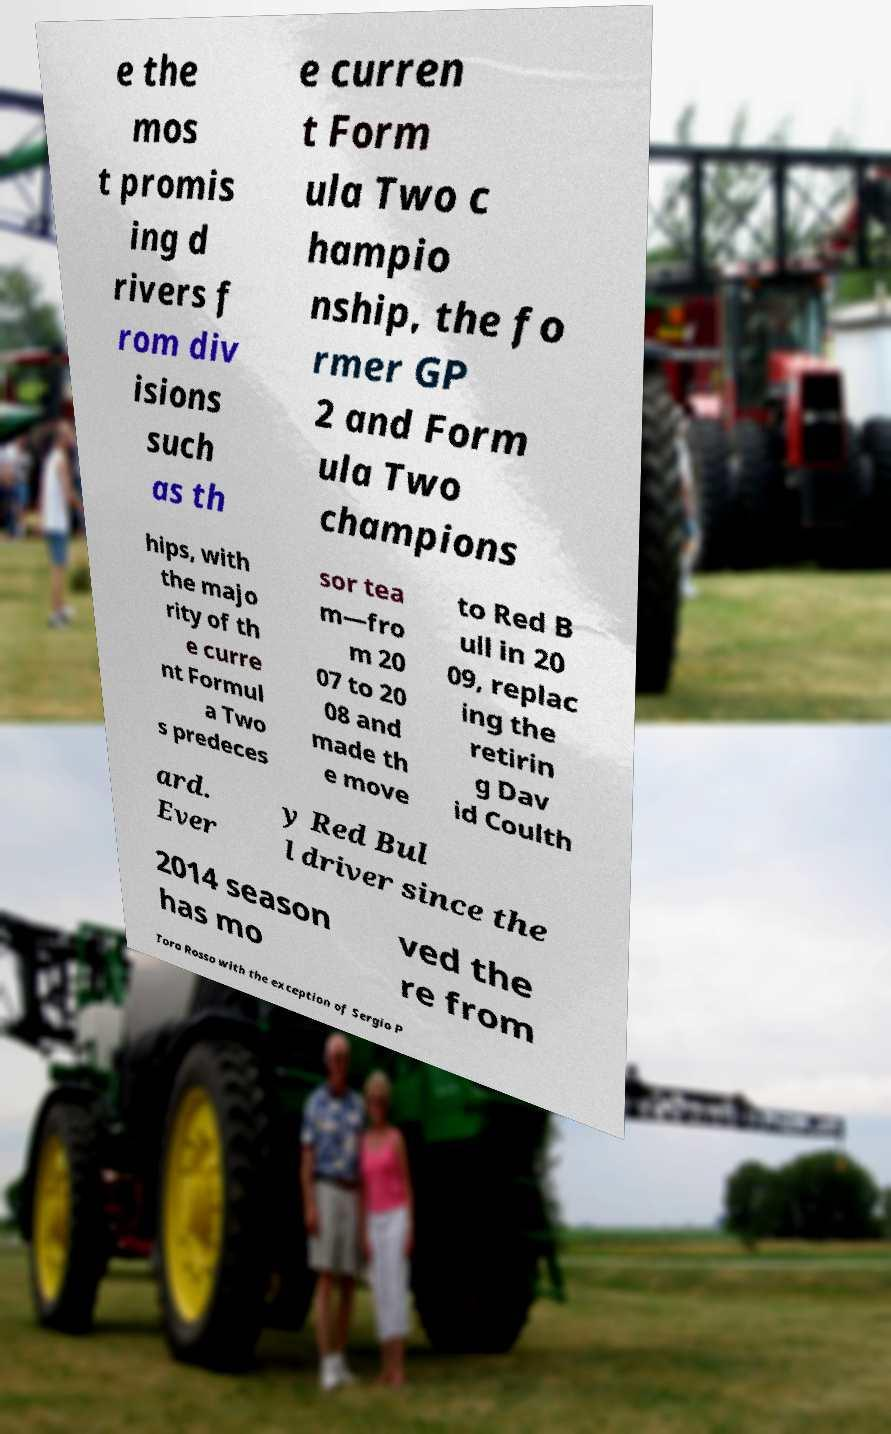Could you assist in decoding the text presented in this image and type it out clearly? e the mos t promis ing d rivers f rom div isions such as th e curren t Form ula Two c hampio nship, the fo rmer GP 2 and Form ula Two champions hips, with the majo rity of th e curre nt Formul a Two s predeces sor tea m—fro m 20 07 to 20 08 and made th e move to Red B ull in 20 09, replac ing the retirin g Dav id Coulth ard. Ever y Red Bul l driver since the 2014 season has mo ved the re from Toro Rosso with the exception of Sergio P 